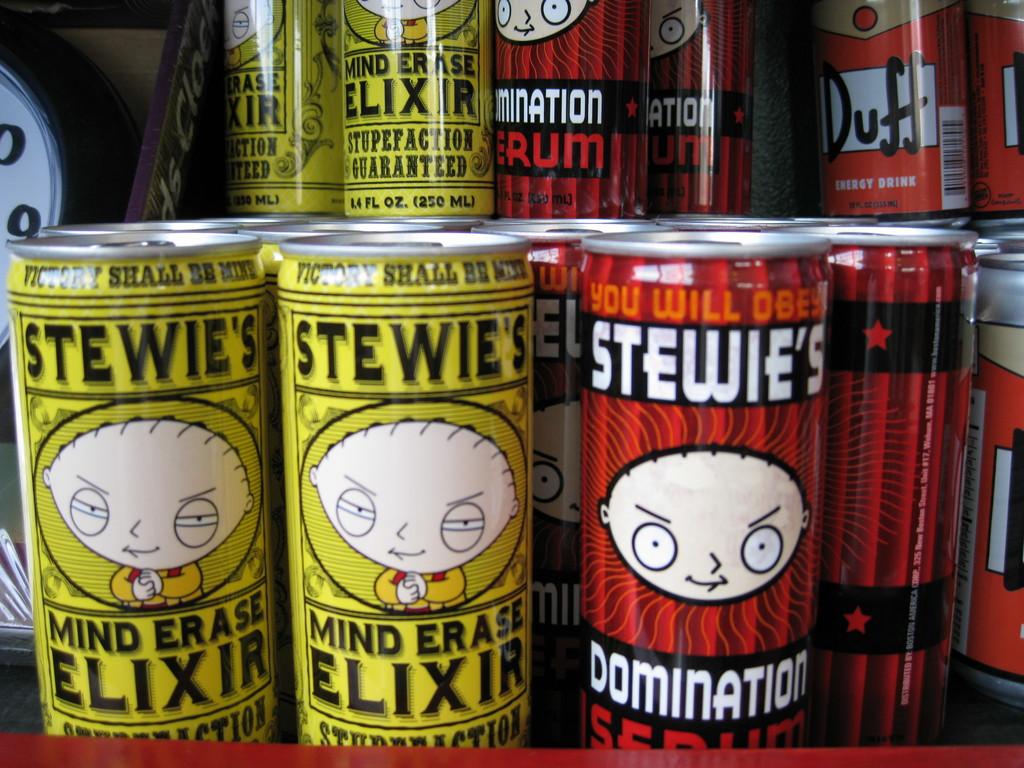What is the name of the stewie's drink in the yellow can?
Provide a short and direct response. Mind erase elixir. What is written on the yellow containers?
Ensure brevity in your answer.  Stewie's mind erase elixir. 